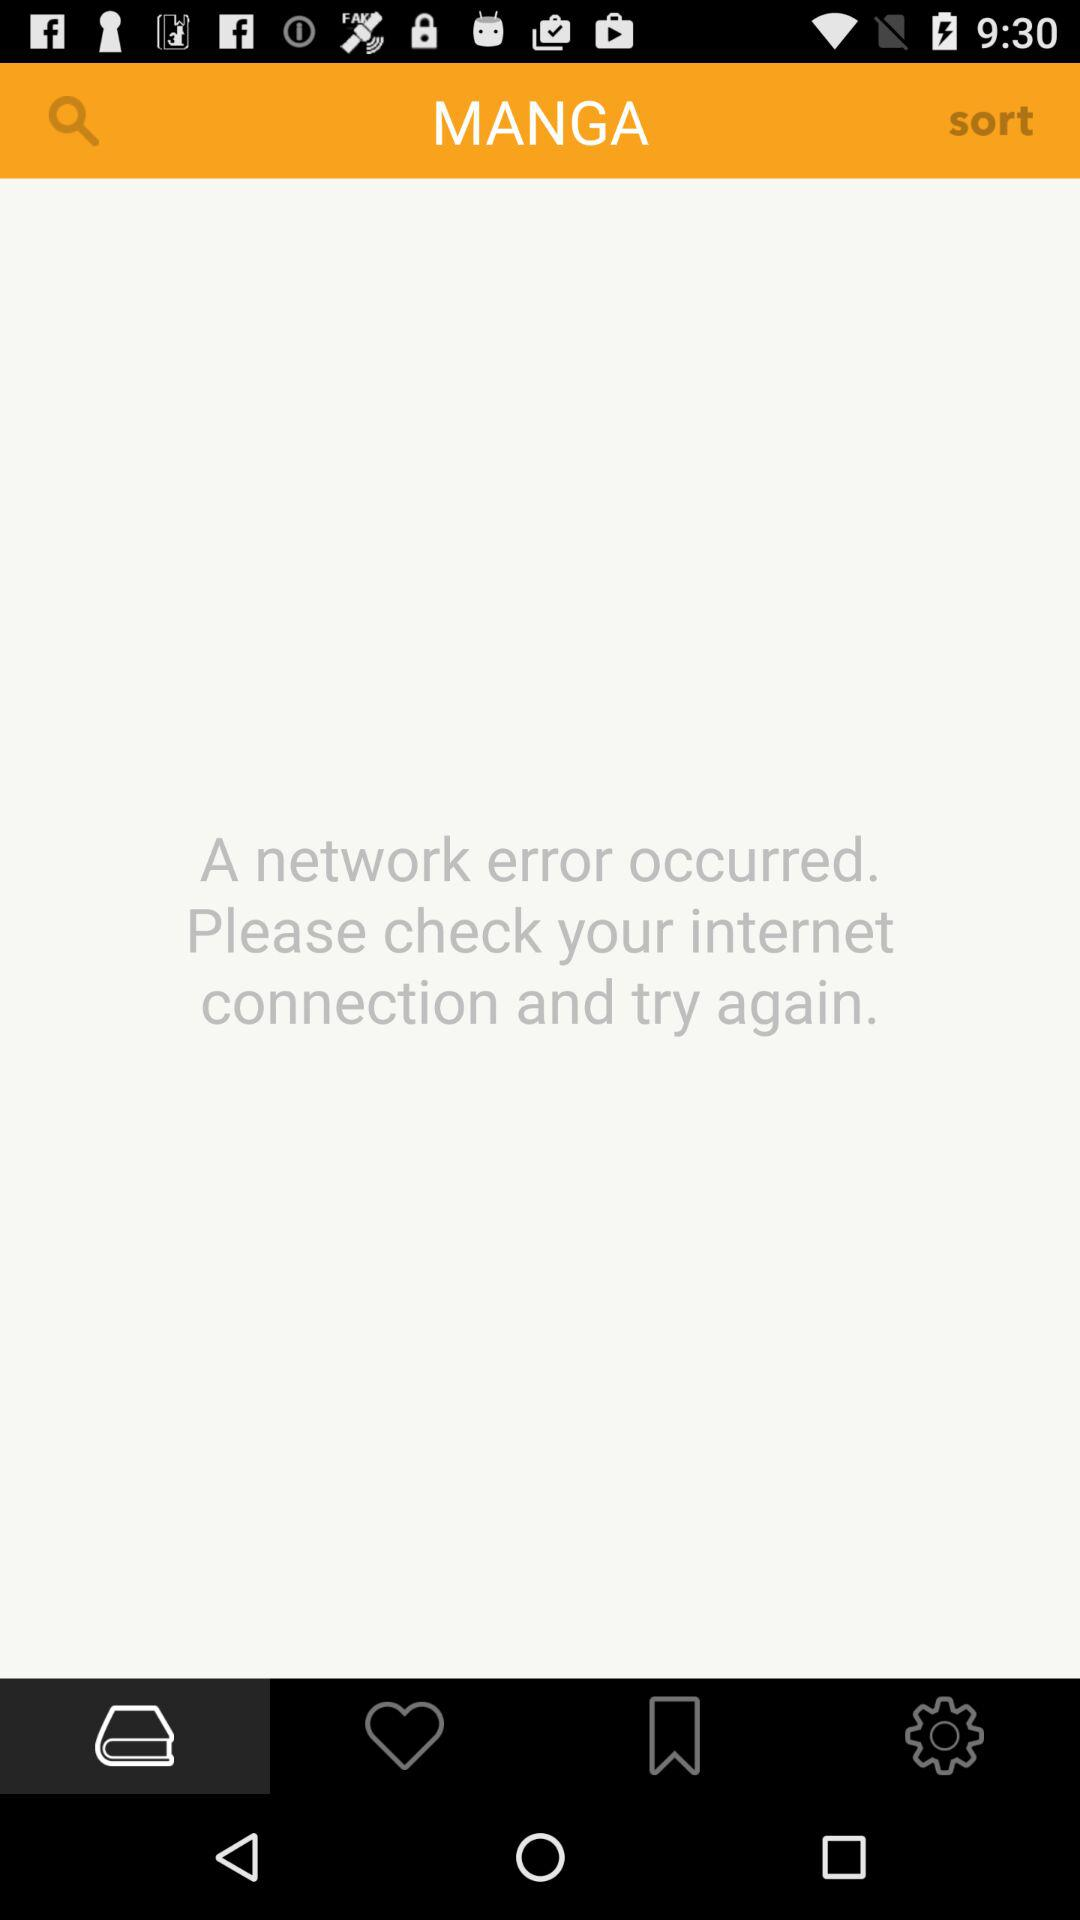What is the application name? The application name is Manga. 